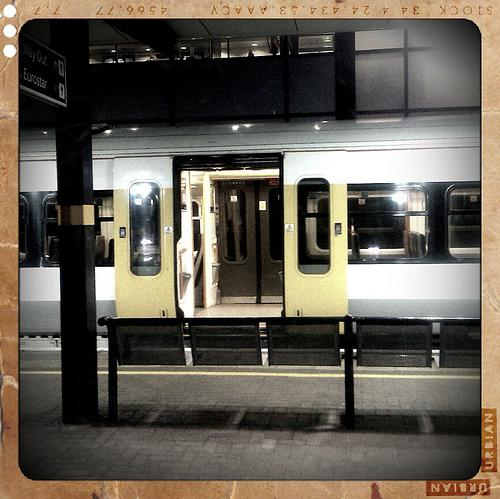Question: how many people are in the picture?
Choices:
A. No one.
B. One.
C. Two.
D. Three.
Answer with the letter. Answer: A Question: what is the picture showing?
Choices:
A. A subway train.
B. A commuter rail.
C. A truck.
D. A school bus.
Answer with the letter. Answer: A Question: what color are the benches?
Choices:
A. Black.
B. Blue.
C. Red.
D. Yellow.
Answer with the letter. Answer: A Question: who is standing in the picture?
Choices:
A. A man.
B. A woman.
C. A child.
D. No one.
Answer with the letter. Answer: D 